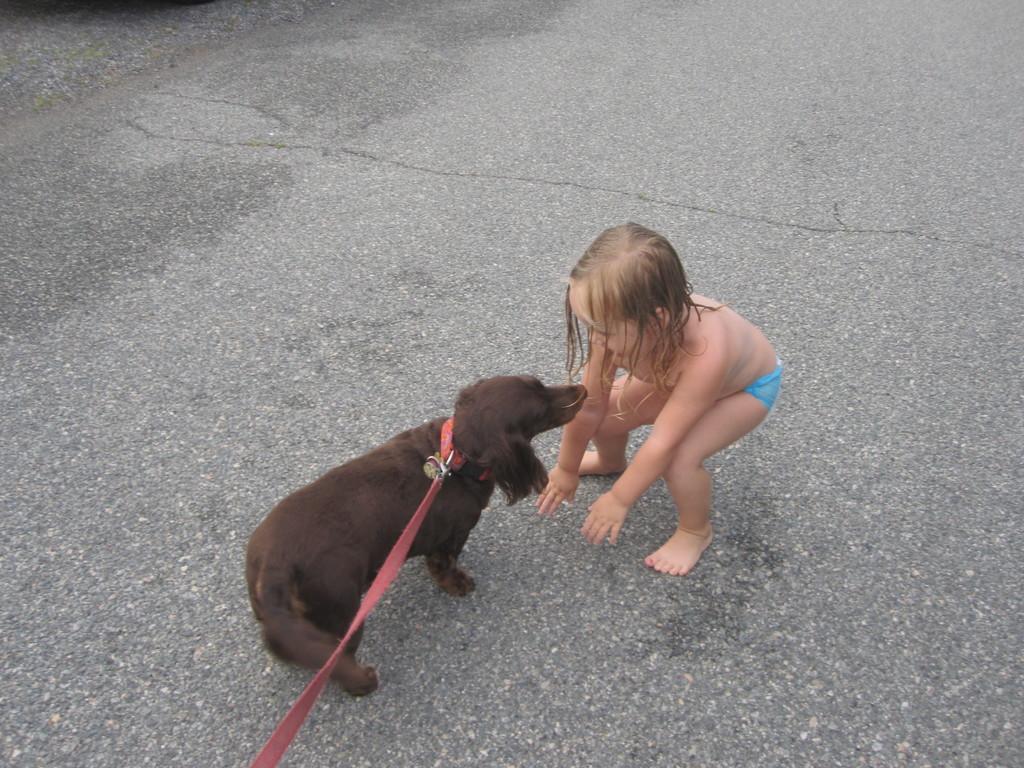Please provide a concise description of this image. In this image I can see a child and a dog. 